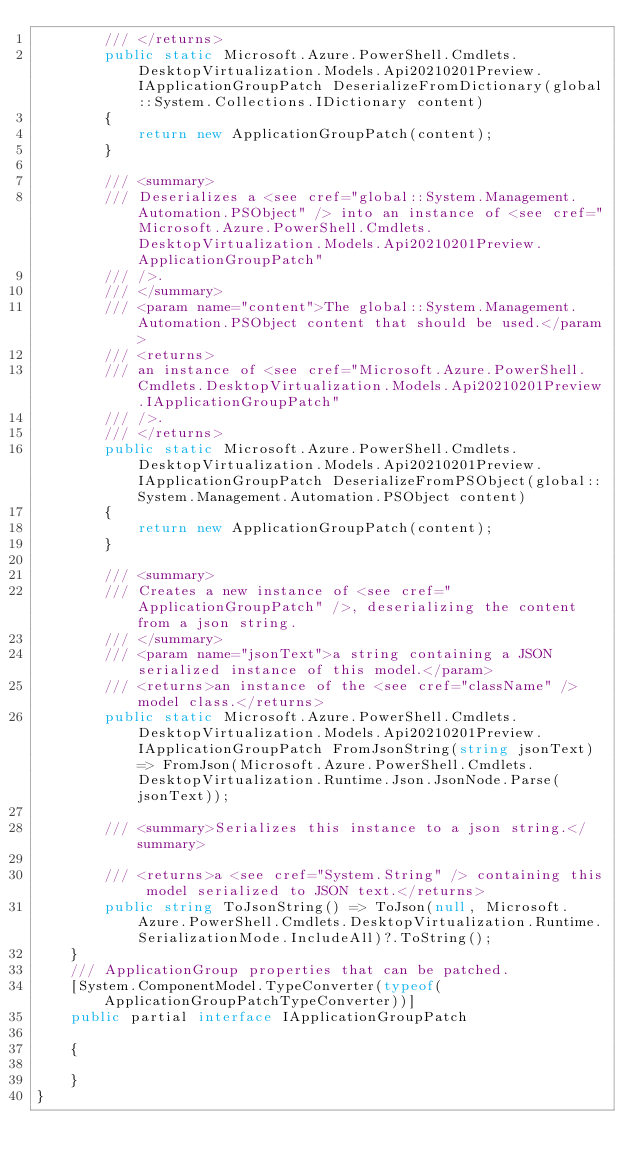Convert code to text. <code><loc_0><loc_0><loc_500><loc_500><_C#_>        /// </returns>
        public static Microsoft.Azure.PowerShell.Cmdlets.DesktopVirtualization.Models.Api20210201Preview.IApplicationGroupPatch DeserializeFromDictionary(global::System.Collections.IDictionary content)
        {
            return new ApplicationGroupPatch(content);
        }

        /// <summary>
        /// Deserializes a <see cref="global::System.Management.Automation.PSObject" /> into an instance of <see cref="Microsoft.Azure.PowerShell.Cmdlets.DesktopVirtualization.Models.Api20210201Preview.ApplicationGroupPatch"
        /// />.
        /// </summary>
        /// <param name="content">The global::System.Management.Automation.PSObject content that should be used.</param>
        /// <returns>
        /// an instance of <see cref="Microsoft.Azure.PowerShell.Cmdlets.DesktopVirtualization.Models.Api20210201Preview.IApplicationGroupPatch"
        /// />.
        /// </returns>
        public static Microsoft.Azure.PowerShell.Cmdlets.DesktopVirtualization.Models.Api20210201Preview.IApplicationGroupPatch DeserializeFromPSObject(global::System.Management.Automation.PSObject content)
        {
            return new ApplicationGroupPatch(content);
        }

        /// <summary>
        /// Creates a new instance of <see cref="ApplicationGroupPatch" />, deserializing the content from a json string.
        /// </summary>
        /// <param name="jsonText">a string containing a JSON serialized instance of this model.</param>
        /// <returns>an instance of the <see cref="className" /> model class.</returns>
        public static Microsoft.Azure.PowerShell.Cmdlets.DesktopVirtualization.Models.Api20210201Preview.IApplicationGroupPatch FromJsonString(string jsonText) => FromJson(Microsoft.Azure.PowerShell.Cmdlets.DesktopVirtualization.Runtime.Json.JsonNode.Parse(jsonText));

        /// <summary>Serializes this instance to a json string.</summary>

        /// <returns>a <see cref="System.String" /> containing this model serialized to JSON text.</returns>
        public string ToJsonString() => ToJson(null, Microsoft.Azure.PowerShell.Cmdlets.DesktopVirtualization.Runtime.SerializationMode.IncludeAll)?.ToString();
    }
    /// ApplicationGroup properties that can be patched.
    [System.ComponentModel.TypeConverter(typeof(ApplicationGroupPatchTypeConverter))]
    public partial interface IApplicationGroupPatch

    {

    }
}</code> 